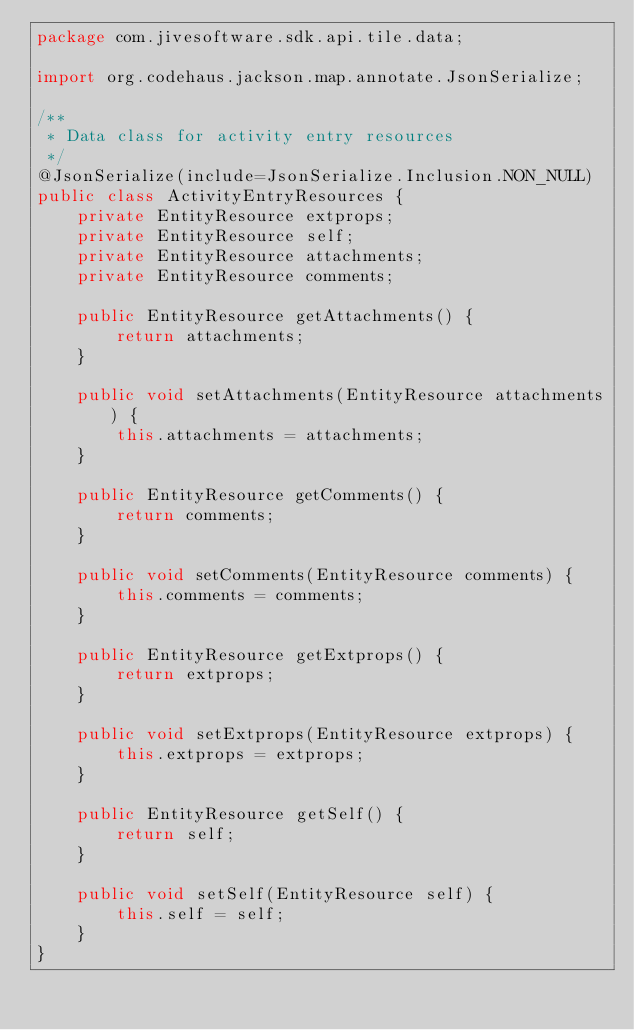<code> <loc_0><loc_0><loc_500><loc_500><_Java_>package com.jivesoftware.sdk.api.tile.data;

import org.codehaus.jackson.map.annotate.JsonSerialize;

/**
 * Data class for activity entry resources
 */
@JsonSerialize(include=JsonSerialize.Inclusion.NON_NULL)
public class ActivityEntryResources {
    private EntityResource extprops;
    private EntityResource self;
    private EntityResource attachments;
    private EntityResource comments;

    public EntityResource getAttachments() {
        return attachments;
    }

    public void setAttachments(EntityResource attachments) {
        this.attachments = attachments;
    }

    public EntityResource getComments() {
        return comments;
    }

    public void setComments(EntityResource comments) {
        this.comments = comments;
    }

    public EntityResource getExtprops() {
        return extprops;
    }

    public void setExtprops(EntityResource extprops) {
        this.extprops = extprops;
    }

    public EntityResource getSelf() {
        return self;
    }

    public void setSelf(EntityResource self) {
        this.self = self;
    }
}
</code> 